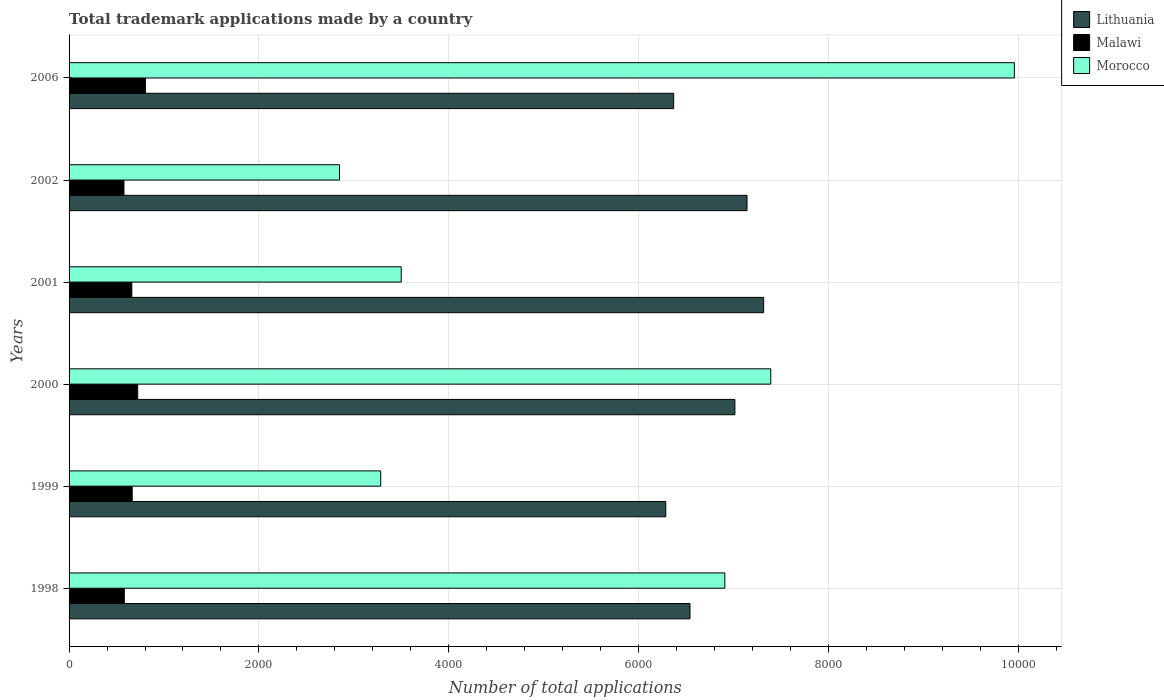How many different coloured bars are there?
Make the answer very short. 3. How many bars are there on the 4th tick from the bottom?
Give a very brief answer. 3. In how many cases, is the number of bars for a given year not equal to the number of legend labels?
Offer a terse response. 0. What is the number of applications made by in Lithuania in 1999?
Provide a succinct answer. 6286. Across all years, what is the maximum number of applications made by in Morocco?
Provide a succinct answer. 9958. Across all years, what is the minimum number of applications made by in Lithuania?
Ensure brevity in your answer.  6286. In which year was the number of applications made by in Malawi maximum?
Your answer should be very brief. 2006. What is the total number of applications made by in Malawi in the graph?
Give a very brief answer. 4013. What is the difference between the number of applications made by in Malawi in 1998 and that in 1999?
Give a very brief answer. -83. What is the difference between the number of applications made by in Malawi in 1999 and the number of applications made by in Morocco in 2002?
Make the answer very short. -2184. What is the average number of applications made by in Malawi per year?
Offer a very short reply. 668.83. In the year 2002, what is the difference between the number of applications made by in Malawi and number of applications made by in Lithuania?
Offer a terse response. -6564. What is the ratio of the number of applications made by in Lithuania in 1999 to that in 2002?
Offer a very short reply. 0.88. Is the number of applications made by in Malawi in 1999 less than that in 2006?
Offer a terse response. Yes. Is the difference between the number of applications made by in Malawi in 1998 and 2000 greater than the difference between the number of applications made by in Lithuania in 1998 and 2000?
Offer a terse response. Yes. What is the difference between the highest and the second highest number of applications made by in Lithuania?
Provide a succinct answer. 175. What is the difference between the highest and the lowest number of applications made by in Morocco?
Your answer should be compact. 7109. In how many years, is the number of applications made by in Malawi greater than the average number of applications made by in Malawi taken over all years?
Give a very brief answer. 2. Is the sum of the number of applications made by in Lithuania in 2000 and 2006 greater than the maximum number of applications made by in Morocco across all years?
Your response must be concise. Yes. What does the 3rd bar from the top in 1999 represents?
Offer a very short reply. Lithuania. What does the 3rd bar from the bottom in 2002 represents?
Your answer should be compact. Morocco. Is it the case that in every year, the sum of the number of applications made by in Lithuania and number of applications made by in Malawi is greater than the number of applications made by in Morocco?
Your response must be concise. No. How many bars are there?
Give a very brief answer. 18. How many years are there in the graph?
Keep it short and to the point. 6. Does the graph contain grids?
Provide a short and direct response. Yes. How many legend labels are there?
Keep it short and to the point. 3. How are the legend labels stacked?
Your answer should be very brief. Vertical. What is the title of the graph?
Provide a succinct answer. Total trademark applications made by a country. What is the label or title of the X-axis?
Your answer should be very brief. Number of total applications. What is the Number of total applications in Lithuania in 1998?
Give a very brief answer. 6541. What is the Number of total applications of Malawi in 1998?
Offer a terse response. 582. What is the Number of total applications of Morocco in 1998?
Offer a terse response. 6908. What is the Number of total applications of Lithuania in 1999?
Provide a succinct answer. 6286. What is the Number of total applications of Malawi in 1999?
Offer a terse response. 665. What is the Number of total applications of Morocco in 1999?
Your answer should be compact. 3283. What is the Number of total applications in Lithuania in 2000?
Make the answer very short. 7014. What is the Number of total applications in Malawi in 2000?
Make the answer very short. 723. What is the Number of total applications in Morocco in 2000?
Your response must be concise. 7392. What is the Number of total applications in Lithuania in 2001?
Provide a short and direct response. 7317. What is the Number of total applications in Malawi in 2001?
Offer a terse response. 661. What is the Number of total applications of Morocco in 2001?
Keep it short and to the point. 3499. What is the Number of total applications of Lithuania in 2002?
Your response must be concise. 7142. What is the Number of total applications in Malawi in 2002?
Ensure brevity in your answer.  578. What is the Number of total applications of Morocco in 2002?
Offer a very short reply. 2849. What is the Number of total applications of Lithuania in 2006?
Your response must be concise. 6369. What is the Number of total applications in Malawi in 2006?
Your response must be concise. 804. What is the Number of total applications in Morocco in 2006?
Keep it short and to the point. 9958. Across all years, what is the maximum Number of total applications of Lithuania?
Give a very brief answer. 7317. Across all years, what is the maximum Number of total applications of Malawi?
Give a very brief answer. 804. Across all years, what is the maximum Number of total applications in Morocco?
Your answer should be compact. 9958. Across all years, what is the minimum Number of total applications of Lithuania?
Your answer should be very brief. 6286. Across all years, what is the minimum Number of total applications of Malawi?
Give a very brief answer. 578. Across all years, what is the minimum Number of total applications of Morocco?
Offer a terse response. 2849. What is the total Number of total applications of Lithuania in the graph?
Provide a short and direct response. 4.07e+04. What is the total Number of total applications in Malawi in the graph?
Your response must be concise. 4013. What is the total Number of total applications of Morocco in the graph?
Ensure brevity in your answer.  3.39e+04. What is the difference between the Number of total applications of Lithuania in 1998 and that in 1999?
Offer a terse response. 255. What is the difference between the Number of total applications in Malawi in 1998 and that in 1999?
Provide a short and direct response. -83. What is the difference between the Number of total applications of Morocco in 1998 and that in 1999?
Your answer should be very brief. 3625. What is the difference between the Number of total applications in Lithuania in 1998 and that in 2000?
Make the answer very short. -473. What is the difference between the Number of total applications of Malawi in 1998 and that in 2000?
Offer a very short reply. -141. What is the difference between the Number of total applications of Morocco in 1998 and that in 2000?
Ensure brevity in your answer.  -484. What is the difference between the Number of total applications of Lithuania in 1998 and that in 2001?
Your answer should be very brief. -776. What is the difference between the Number of total applications in Malawi in 1998 and that in 2001?
Provide a succinct answer. -79. What is the difference between the Number of total applications of Morocco in 1998 and that in 2001?
Provide a short and direct response. 3409. What is the difference between the Number of total applications of Lithuania in 1998 and that in 2002?
Provide a short and direct response. -601. What is the difference between the Number of total applications of Morocco in 1998 and that in 2002?
Provide a short and direct response. 4059. What is the difference between the Number of total applications of Lithuania in 1998 and that in 2006?
Your answer should be compact. 172. What is the difference between the Number of total applications of Malawi in 1998 and that in 2006?
Give a very brief answer. -222. What is the difference between the Number of total applications of Morocco in 1998 and that in 2006?
Provide a succinct answer. -3050. What is the difference between the Number of total applications in Lithuania in 1999 and that in 2000?
Offer a terse response. -728. What is the difference between the Number of total applications of Malawi in 1999 and that in 2000?
Offer a terse response. -58. What is the difference between the Number of total applications in Morocco in 1999 and that in 2000?
Offer a very short reply. -4109. What is the difference between the Number of total applications in Lithuania in 1999 and that in 2001?
Keep it short and to the point. -1031. What is the difference between the Number of total applications of Morocco in 1999 and that in 2001?
Your response must be concise. -216. What is the difference between the Number of total applications in Lithuania in 1999 and that in 2002?
Keep it short and to the point. -856. What is the difference between the Number of total applications of Morocco in 1999 and that in 2002?
Keep it short and to the point. 434. What is the difference between the Number of total applications of Lithuania in 1999 and that in 2006?
Give a very brief answer. -83. What is the difference between the Number of total applications of Malawi in 1999 and that in 2006?
Provide a succinct answer. -139. What is the difference between the Number of total applications of Morocco in 1999 and that in 2006?
Your response must be concise. -6675. What is the difference between the Number of total applications of Lithuania in 2000 and that in 2001?
Your answer should be very brief. -303. What is the difference between the Number of total applications in Malawi in 2000 and that in 2001?
Offer a very short reply. 62. What is the difference between the Number of total applications of Morocco in 2000 and that in 2001?
Your answer should be compact. 3893. What is the difference between the Number of total applications in Lithuania in 2000 and that in 2002?
Offer a very short reply. -128. What is the difference between the Number of total applications in Malawi in 2000 and that in 2002?
Your answer should be compact. 145. What is the difference between the Number of total applications in Morocco in 2000 and that in 2002?
Provide a short and direct response. 4543. What is the difference between the Number of total applications in Lithuania in 2000 and that in 2006?
Keep it short and to the point. 645. What is the difference between the Number of total applications in Malawi in 2000 and that in 2006?
Your answer should be compact. -81. What is the difference between the Number of total applications in Morocco in 2000 and that in 2006?
Provide a succinct answer. -2566. What is the difference between the Number of total applications of Lithuania in 2001 and that in 2002?
Provide a succinct answer. 175. What is the difference between the Number of total applications of Morocco in 2001 and that in 2002?
Make the answer very short. 650. What is the difference between the Number of total applications of Lithuania in 2001 and that in 2006?
Offer a terse response. 948. What is the difference between the Number of total applications of Malawi in 2001 and that in 2006?
Give a very brief answer. -143. What is the difference between the Number of total applications of Morocco in 2001 and that in 2006?
Give a very brief answer. -6459. What is the difference between the Number of total applications in Lithuania in 2002 and that in 2006?
Your answer should be compact. 773. What is the difference between the Number of total applications in Malawi in 2002 and that in 2006?
Keep it short and to the point. -226. What is the difference between the Number of total applications of Morocco in 2002 and that in 2006?
Provide a succinct answer. -7109. What is the difference between the Number of total applications in Lithuania in 1998 and the Number of total applications in Malawi in 1999?
Provide a short and direct response. 5876. What is the difference between the Number of total applications of Lithuania in 1998 and the Number of total applications of Morocco in 1999?
Provide a succinct answer. 3258. What is the difference between the Number of total applications of Malawi in 1998 and the Number of total applications of Morocco in 1999?
Your answer should be very brief. -2701. What is the difference between the Number of total applications of Lithuania in 1998 and the Number of total applications of Malawi in 2000?
Offer a terse response. 5818. What is the difference between the Number of total applications in Lithuania in 1998 and the Number of total applications in Morocco in 2000?
Make the answer very short. -851. What is the difference between the Number of total applications in Malawi in 1998 and the Number of total applications in Morocco in 2000?
Offer a terse response. -6810. What is the difference between the Number of total applications in Lithuania in 1998 and the Number of total applications in Malawi in 2001?
Ensure brevity in your answer.  5880. What is the difference between the Number of total applications of Lithuania in 1998 and the Number of total applications of Morocco in 2001?
Your answer should be very brief. 3042. What is the difference between the Number of total applications of Malawi in 1998 and the Number of total applications of Morocco in 2001?
Offer a terse response. -2917. What is the difference between the Number of total applications in Lithuania in 1998 and the Number of total applications in Malawi in 2002?
Your answer should be compact. 5963. What is the difference between the Number of total applications in Lithuania in 1998 and the Number of total applications in Morocco in 2002?
Keep it short and to the point. 3692. What is the difference between the Number of total applications in Malawi in 1998 and the Number of total applications in Morocco in 2002?
Provide a succinct answer. -2267. What is the difference between the Number of total applications in Lithuania in 1998 and the Number of total applications in Malawi in 2006?
Make the answer very short. 5737. What is the difference between the Number of total applications in Lithuania in 1998 and the Number of total applications in Morocco in 2006?
Make the answer very short. -3417. What is the difference between the Number of total applications in Malawi in 1998 and the Number of total applications in Morocco in 2006?
Ensure brevity in your answer.  -9376. What is the difference between the Number of total applications of Lithuania in 1999 and the Number of total applications of Malawi in 2000?
Offer a very short reply. 5563. What is the difference between the Number of total applications of Lithuania in 1999 and the Number of total applications of Morocco in 2000?
Your answer should be very brief. -1106. What is the difference between the Number of total applications in Malawi in 1999 and the Number of total applications in Morocco in 2000?
Your answer should be very brief. -6727. What is the difference between the Number of total applications in Lithuania in 1999 and the Number of total applications in Malawi in 2001?
Ensure brevity in your answer.  5625. What is the difference between the Number of total applications of Lithuania in 1999 and the Number of total applications of Morocco in 2001?
Your response must be concise. 2787. What is the difference between the Number of total applications in Malawi in 1999 and the Number of total applications in Morocco in 2001?
Offer a very short reply. -2834. What is the difference between the Number of total applications of Lithuania in 1999 and the Number of total applications of Malawi in 2002?
Give a very brief answer. 5708. What is the difference between the Number of total applications of Lithuania in 1999 and the Number of total applications of Morocco in 2002?
Your answer should be compact. 3437. What is the difference between the Number of total applications of Malawi in 1999 and the Number of total applications of Morocco in 2002?
Provide a short and direct response. -2184. What is the difference between the Number of total applications of Lithuania in 1999 and the Number of total applications of Malawi in 2006?
Your answer should be very brief. 5482. What is the difference between the Number of total applications in Lithuania in 1999 and the Number of total applications in Morocco in 2006?
Your answer should be compact. -3672. What is the difference between the Number of total applications in Malawi in 1999 and the Number of total applications in Morocco in 2006?
Make the answer very short. -9293. What is the difference between the Number of total applications in Lithuania in 2000 and the Number of total applications in Malawi in 2001?
Your response must be concise. 6353. What is the difference between the Number of total applications in Lithuania in 2000 and the Number of total applications in Morocco in 2001?
Provide a succinct answer. 3515. What is the difference between the Number of total applications of Malawi in 2000 and the Number of total applications of Morocco in 2001?
Offer a very short reply. -2776. What is the difference between the Number of total applications in Lithuania in 2000 and the Number of total applications in Malawi in 2002?
Your answer should be compact. 6436. What is the difference between the Number of total applications of Lithuania in 2000 and the Number of total applications of Morocco in 2002?
Make the answer very short. 4165. What is the difference between the Number of total applications in Malawi in 2000 and the Number of total applications in Morocco in 2002?
Give a very brief answer. -2126. What is the difference between the Number of total applications in Lithuania in 2000 and the Number of total applications in Malawi in 2006?
Provide a short and direct response. 6210. What is the difference between the Number of total applications in Lithuania in 2000 and the Number of total applications in Morocco in 2006?
Offer a very short reply. -2944. What is the difference between the Number of total applications of Malawi in 2000 and the Number of total applications of Morocco in 2006?
Ensure brevity in your answer.  -9235. What is the difference between the Number of total applications of Lithuania in 2001 and the Number of total applications of Malawi in 2002?
Ensure brevity in your answer.  6739. What is the difference between the Number of total applications in Lithuania in 2001 and the Number of total applications in Morocco in 2002?
Provide a short and direct response. 4468. What is the difference between the Number of total applications of Malawi in 2001 and the Number of total applications of Morocco in 2002?
Give a very brief answer. -2188. What is the difference between the Number of total applications in Lithuania in 2001 and the Number of total applications in Malawi in 2006?
Your answer should be compact. 6513. What is the difference between the Number of total applications in Lithuania in 2001 and the Number of total applications in Morocco in 2006?
Offer a very short reply. -2641. What is the difference between the Number of total applications in Malawi in 2001 and the Number of total applications in Morocco in 2006?
Your answer should be very brief. -9297. What is the difference between the Number of total applications of Lithuania in 2002 and the Number of total applications of Malawi in 2006?
Your response must be concise. 6338. What is the difference between the Number of total applications of Lithuania in 2002 and the Number of total applications of Morocco in 2006?
Offer a terse response. -2816. What is the difference between the Number of total applications in Malawi in 2002 and the Number of total applications in Morocco in 2006?
Keep it short and to the point. -9380. What is the average Number of total applications in Lithuania per year?
Offer a very short reply. 6778.17. What is the average Number of total applications of Malawi per year?
Give a very brief answer. 668.83. What is the average Number of total applications in Morocco per year?
Your answer should be compact. 5648.17. In the year 1998, what is the difference between the Number of total applications of Lithuania and Number of total applications of Malawi?
Your response must be concise. 5959. In the year 1998, what is the difference between the Number of total applications of Lithuania and Number of total applications of Morocco?
Make the answer very short. -367. In the year 1998, what is the difference between the Number of total applications in Malawi and Number of total applications in Morocco?
Give a very brief answer. -6326. In the year 1999, what is the difference between the Number of total applications in Lithuania and Number of total applications in Malawi?
Your answer should be very brief. 5621. In the year 1999, what is the difference between the Number of total applications of Lithuania and Number of total applications of Morocco?
Keep it short and to the point. 3003. In the year 1999, what is the difference between the Number of total applications of Malawi and Number of total applications of Morocco?
Offer a terse response. -2618. In the year 2000, what is the difference between the Number of total applications of Lithuania and Number of total applications of Malawi?
Provide a short and direct response. 6291. In the year 2000, what is the difference between the Number of total applications of Lithuania and Number of total applications of Morocco?
Provide a short and direct response. -378. In the year 2000, what is the difference between the Number of total applications of Malawi and Number of total applications of Morocco?
Keep it short and to the point. -6669. In the year 2001, what is the difference between the Number of total applications in Lithuania and Number of total applications in Malawi?
Provide a short and direct response. 6656. In the year 2001, what is the difference between the Number of total applications in Lithuania and Number of total applications in Morocco?
Make the answer very short. 3818. In the year 2001, what is the difference between the Number of total applications in Malawi and Number of total applications in Morocco?
Give a very brief answer. -2838. In the year 2002, what is the difference between the Number of total applications in Lithuania and Number of total applications in Malawi?
Provide a succinct answer. 6564. In the year 2002, what is the difference between the Number of total applications of Lithuania and Number of total applications of Morocco?
Offer a terse response. 4293. In the year 2002, what is the difference between the Number of total applications in Malawi and Number of total applications in Morocco?
Offer a very short reply. -2271. In the year 2006, what is the difference between the Number of total applications of Lithuania and Number of total applications of Malawi?
Provide a succinct answer. 5565. In the year 2006, what is the difference between the Number of total applications of Lithuania and Number of total applications of Morocco?
Provide a succinct answer. -3589. In the year 2006, what is the difference between the Number of total applications of Malawi and Number of total applications of Morocco?
Provide a short and direct response. -9154. What is the ratio of the Number of total applications of Lithuania in 1998 to that in 1999?
Offer a terse response. 1.04. What is the ratio of the Number of total applications in Malawi in 1998 to that in 1999?
Give a very brief answer. 0.88. What is the ratio of the Number of total applications of Morocco in 1998 to that in 1999?
Offer a terse response. 2.1. What is the ratio of the Number of total applications in Lithuania in 1998 to that in 2000?
Offer a terse response. 0.93. What is the ratio of the Number of total applications of Malawi in 1998 to that in 2000?
Make the answer very short. 0.81. What is the ratio of the Number of total applications in Morocco in 1998 to that in 2000?
Your answer should be compact. 0.93. What is the ratio of the Number of total applications in Lithuania in 1998 to that in 2001?
Provide a short and direct response. 0.89. What is the ratio of the Number of total applications in Malawi in 1998 to that in 2001?
Provide a succinct answer. 0.88. What is the ratio of the Number of total applications of Morocco in 1998 to that in 2001?
Provide a short and direct response. 1.97. What is the ratio of the Number of total applications of Lithuania in 1998 to that in 2002?
Your answer should be very brief. 0.92. What is the ratio of the Number of total applications in Morocco in 1998 to that in 2002?
Your answer should be compact. 2.42. What is the ratio of the Number of total applications of Malawi in 1998 to that in 2006?
Your response must be concise. 0.72. What is the ratio of the Number of total applications of Morocco in 1998 to that in 2006?
Your response must be concise. 0.69. What is the ratio of the Number of total applications of Lithuania in 1999 to that in 2000?
Your answer should be compact. 0.9. What is the ratio of the Number of total applications in Malawi in 1999 to that in 2000?
Offer a very short reply. 0.92. What is the ratio of the Number of total applications in Morocco in 1999 to that in 2000?
Ensure brevity in your answer.  0.44. What is the ratio of the Number of total applications in Lithuania in 1999 to that in 2001?
Make the answer very short. 0.86. What is the ratio of the Number of total applications of Malawi in 1999 to that in 2001?
Make the answer very short. 1.01. What is the ratio of the Number of total applications in Morocco in 1999 to that in 2001?
Make the answer very short. 0.94. What is the ratio of the Number of total applications in Lithuania in 1999 to that in 2002?
Your answer should be very brief. 0.88. What is the ratio of the Number of total applications of Malawi in 1999 to that in 2002?
Offer a very short reply. 1.15. What is the ratio of the Number of total applications of Morocco in 1999 to that in 2002?
Keep it short and to the point. 1.15. What is the ratio of the Number of total applications in Lithuania in 1999 to that in 2006?
Your answer should be compact. 0.99. What is the ratio of the Number of total applications of Malawi in 1999 to that in 2006?
Make the answer very short. 0.83. What is the ratio of the Number of total applications in Morocco in 1999 to that in 2006?
Keep it short and to the point. 0.33. What is the ratio of the Number of total applications of Lithuania in 2000 to that in 2001?
Ensure brevity in your answer.  0.96. What is the ratio of the Number of total applications of Malawi in 2000 to that in 2001?
Make the answer very short. 1.09. What is the ratio of the Number of total applications of Morocco in 2000 to that in 2001?
Make the answer very short. 2.11. What is the ratio of the Number of total applications in Lithuania in 2000 to that in 2002?
Offer a terse response. 0.98. What is the ratio of the Number of total applications of Malawi in 2000 to that in 2002?
Offer a very short reply. 1.25. What is the ratio of the Number of total applications in Morocco in 2000 to that in 2002?
Give a very brief answer. 2.59. What is the ratio of the Number of total applications in Lithuania in 2000 to that in 2006?
Ensure brevity in your answer.  1.1. What is the ratio of the Number of total applications of Malawi in 2000 to that in 2006?
Your response must be concise. 0.9. What is the ratio of the Number of total applications in Morocco in 2000 to that in 2006?
Make the answer very short. 0.74. What is the ratio of the Number of total applications in Lithuania in 2001 to that in 2002?
Your answer should be very brief. 1.02. What is the ratio of the Number of total applications of Malawi in 2001 to that in 2002?
Give a very brief answer. 1.14. What is the ratio of the Number of total applications of Morocco in 2001 to that in 2002?
Provide a succinct answer. 1.23. What is the ratio of the Number of total applications in Lithuania in 2001 to that in 2006?
Make the answer very short. 1.15. What is the ratio of the Number of total applications in Malawi in 2001 to that in 2006?
Offer a very short reply. 0.82. What is the ratio of the Number of total applications in Morocco in 2001 to that in 2006?
Ensure brevity in your answer.  0.35. What is the ratio of the Number of total applications in Lithuania in 2002 to that in 2006?
Make the answer very short. 1.12. What is the ratio of the Number of total applications in Malawi in 2002 to that in 2006?
Give a very brief answer. 0.72. What is the ratio of the Number of total applications of Morocco in 2002 to that in 2006?
Your answer should be compact. 0.29. What is the difference between the highest and the second highest Number of total applications in Lithuania?
Provide a succinct answer. 175. What is the difference between the highest and the second highest Number of total applications in Malawi?
Offer a terse response. 81. What is the difference between the highest and the second highest Number of total applications in Morocco?
Offer a terse response. 2566. What is the difference between the highest and the lowest Number of total applications of Lithuania?
Offer a very short reply. 1031. What is the difference between the highest and the lowest Number of total applications of Malawi?
Offer a terse response. 226. What is the difference between the highest and the lowest Number of total applications in Morocco?
Make the answer very short. 7109. 